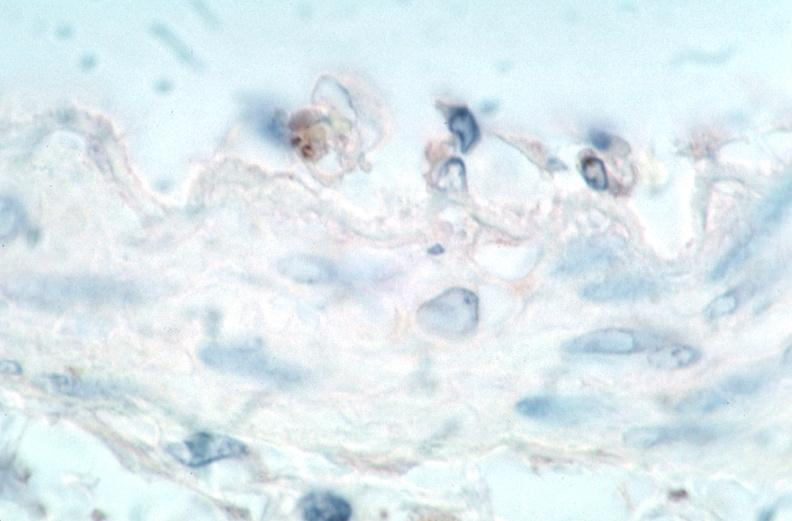what is rocky mountain spotted?
Answer the question using a single word or phrase. Fever 